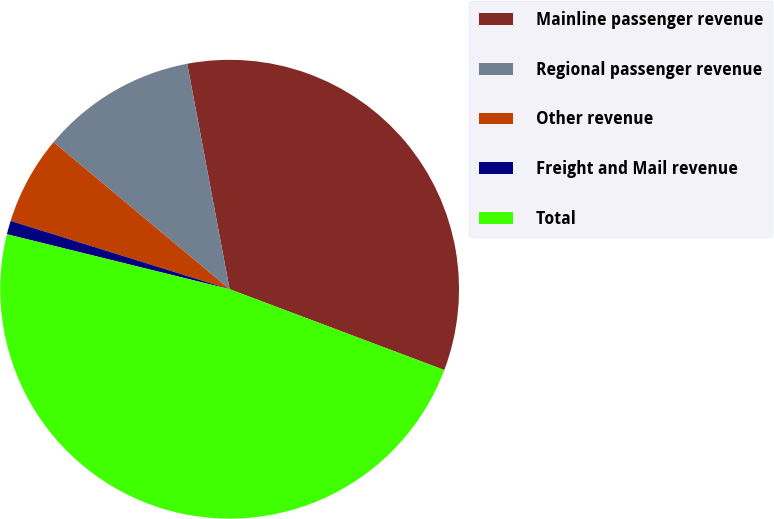Convert chart to OTSL. <chart><loc_0><loc_0><loc_500><loc_500><pie_chart><fcel>Mainline passenger revenue<fcel>Regional passenger revenue<fcel>Other revenue<fcel>Freight and Mail revenue<fcel>Total<nl><fcel>33.69%<fcel>10.97%<fcel>6.26%<fcel>0.96%<fcel>48.12%<nl></chart> 